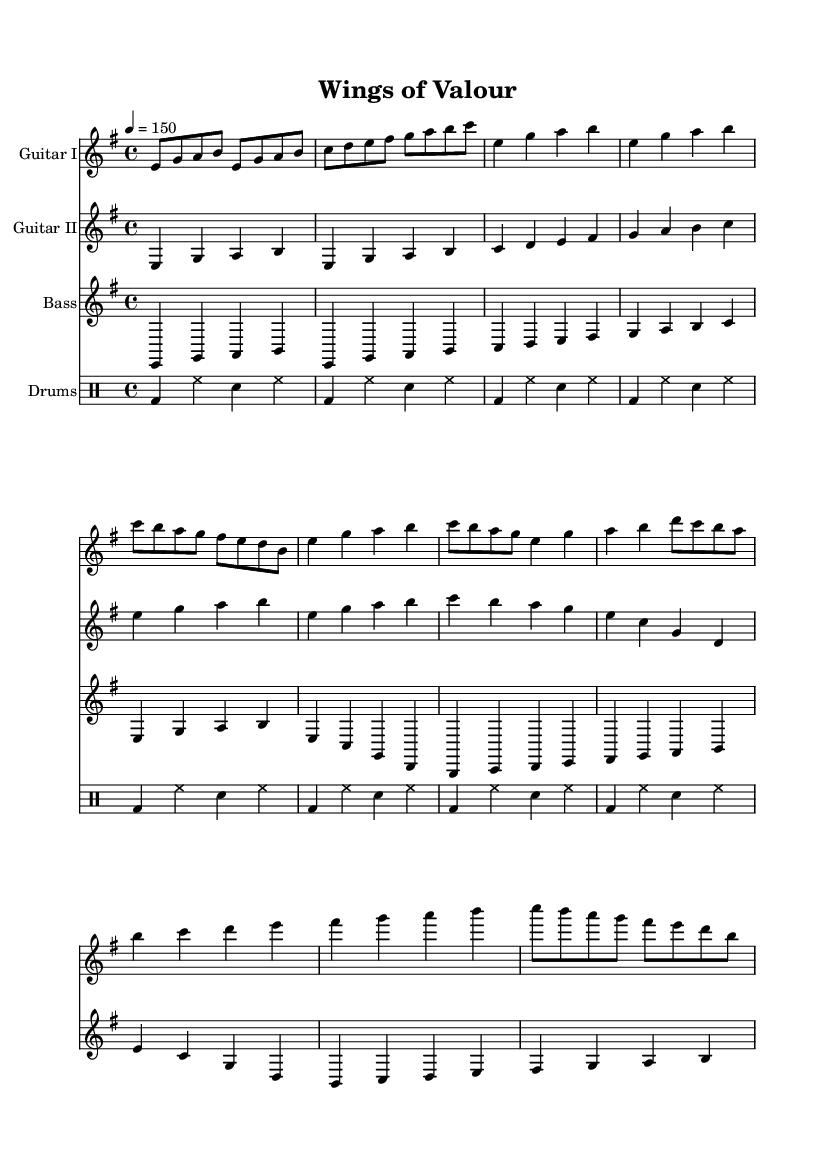What is the key signature of this music? The key signature indicated in the music is E minor, which has one sharp (F#).
Answer: E minor What is the time signature of this music? The time signature shown in the music is 4/4, meaning there are four beats per measure.
Answer: 4/4 What is the tempo marking for this music? The tempo is marked at 150 beats per minute, indicating the speed at which the piece should be played.
Answer: 150 How many sections are there in the song structure? The sheet music includes an Intro, Verse, Chorus, and Bridge, totaling four distinct sections.
Answer: Four What is the primary instrument type featured in this music? The primary instruments in the piece are guitar, bass, and drums, typical in heavy metal music.
Answer: Guitar, Bass, Drums Which power chord progression is used in the verse? The verse uses the chord progression of E minor, G major, A major, B major, and C major, common in rock and metal genres.
Answer: E minor, G major, A major, B major What is the role of the drums in this piece? The drums provide a basic rock beat, supporting the rhythm and energy typical in power metal.
Answer: Basic rock beat 